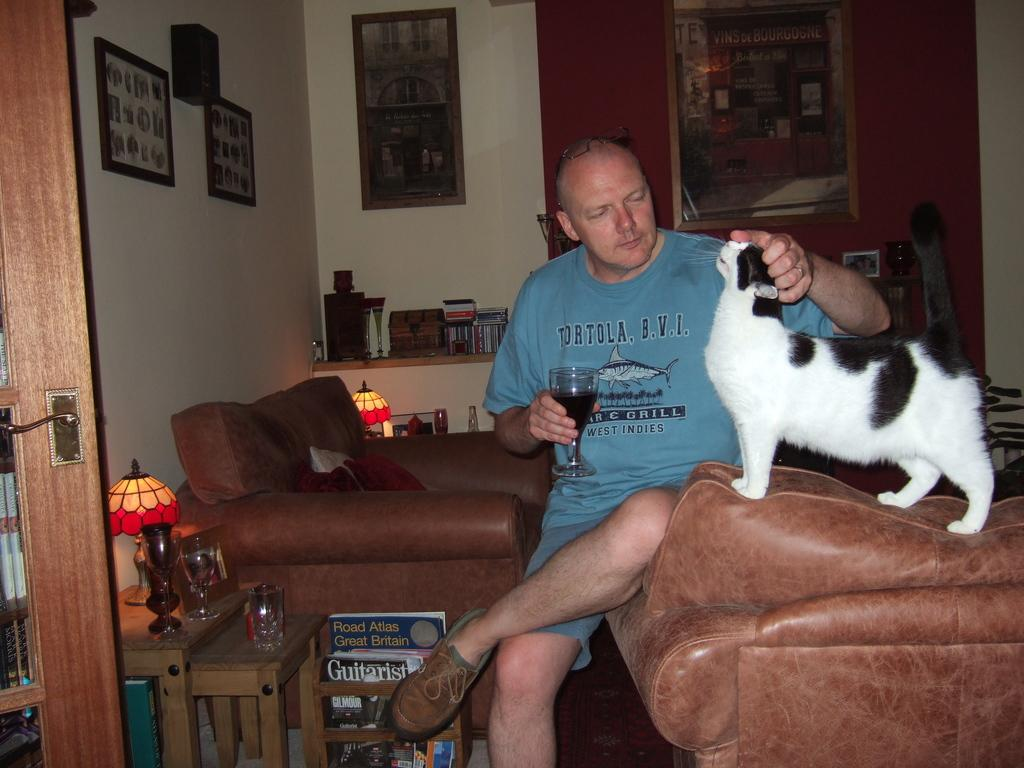<image>
Write a terse but informative summary of the picture. A man wearing a shirt that says 'tortola, b.v.i.' 